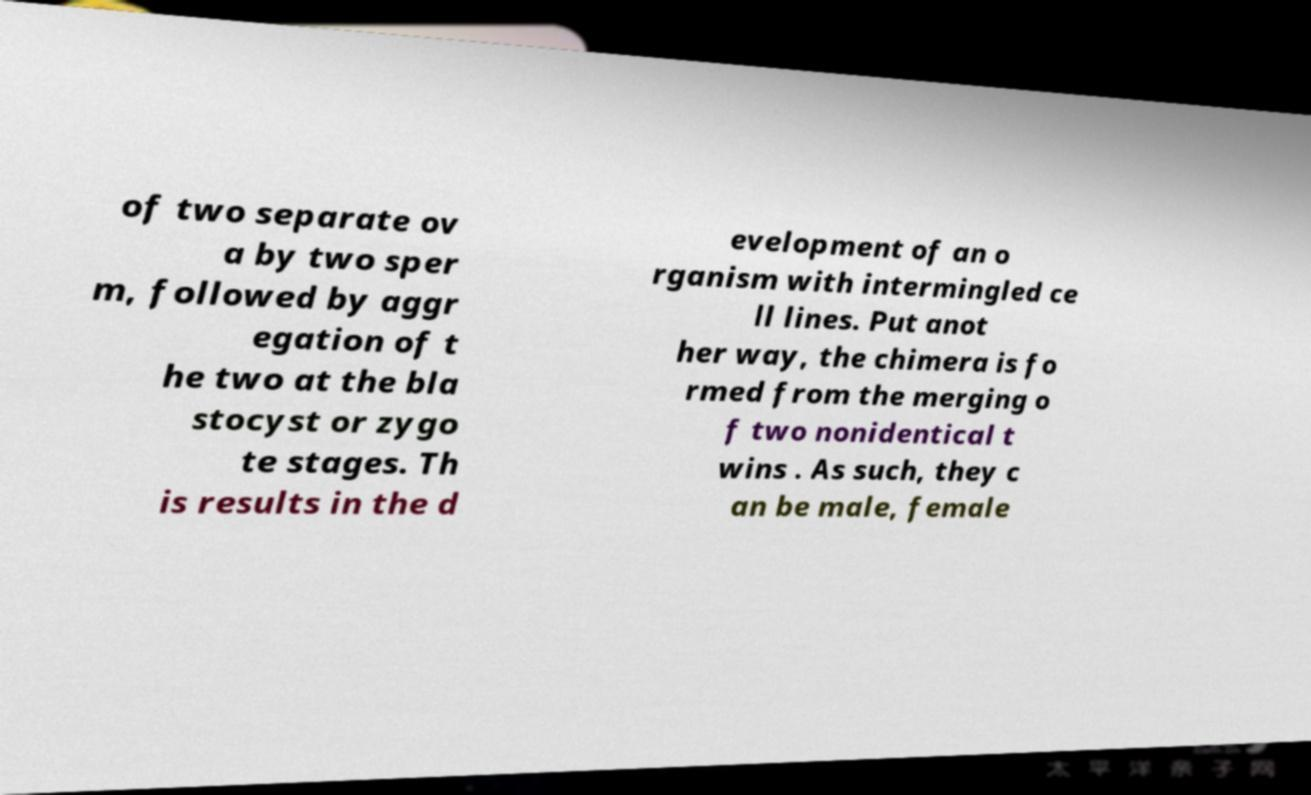For documentation purposes, I need the text within this image transcribed. Could you provide that? of two separate ov a by two sper m, followed by aggr egation of t he two at the bla stocyst or zygo te stages. Th is results in the d evelopment of an o rganism with intermingled ce ll lines. Put anot her way, the chimera is fo rmed from the merging o f two nonidentical t wins . As such, they c an be male, female 